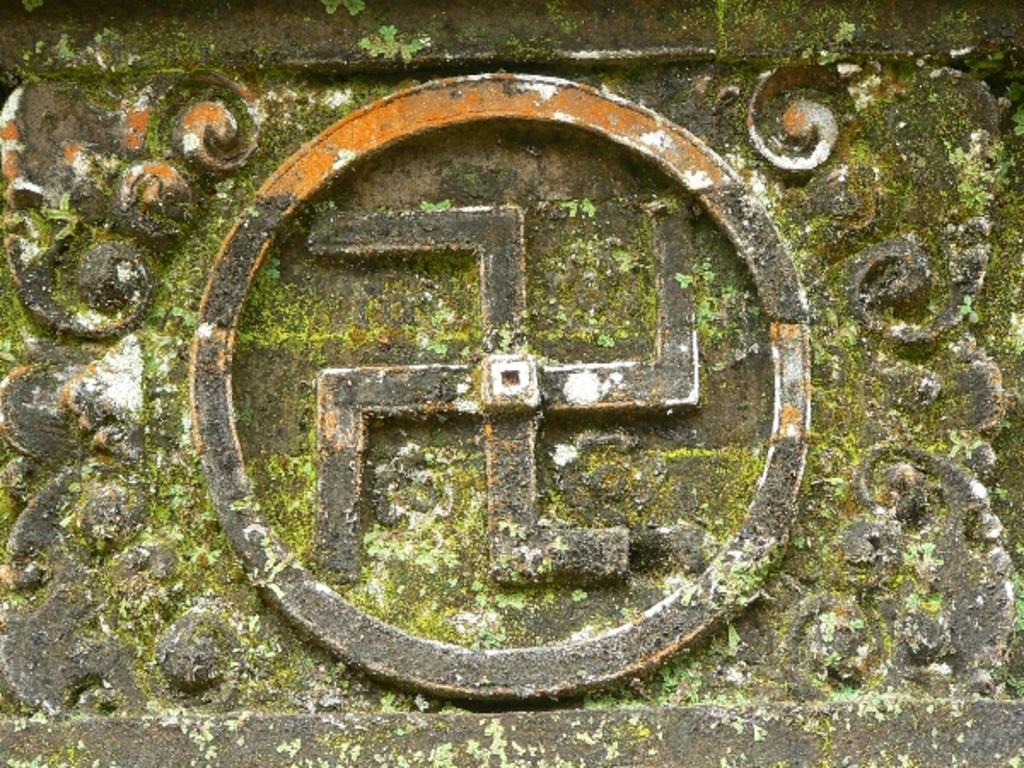What is the appearance of the stone plate in the image? The stone plate has designs on it. What additional feature can be seen on the stone plate? There is a symbol on the stone plate. How does the stone plate support the mother in the image? There is no mother present in the image, and the stone plate is not supporting anyone. 